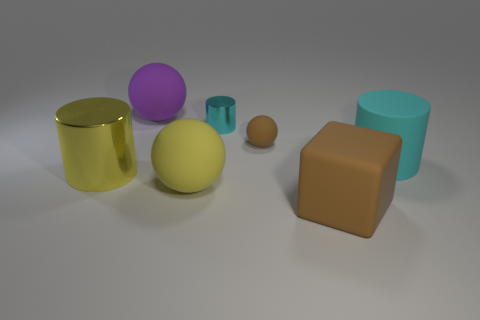Is there another tiny cyan object of the same shape as the small matte object?
Make the answer very short. No. Is the material of the cyan cylinder behind the brown sphere the same as the brown block that is in front of the big purple matte ball?
Offer a very short reply. No. What is the size of the metallic object that is on the right side of the large rubber ball in front of the large purple sphere that is to the left of the big brown block?
Ensure brevity in your answer.  Small. There is a sphere that is the same size as the cyan metallic cylinder; what is it made of?
Your answer should be compact. Rubber. Are there any green cylinders of the same size as the cyan metallic cylinder?
Provide a succinct answer. No. Do the big brown object and the small cyan shiny thing have the same shape?
Make the answer very short. No. Is there a large yellow sphere that is left of the brown thing that is to the left of the brown matte thing in front of the small rubber sphere?
Offer a very short reply. Yes. Does the brown matte thing behind the big yellow cylinder have the same size as the cyan cylinder to the right of the tiny metallic cylinder?
Your answer should be very brief. No. Is the number of large yellow cylinders that are behind the big brown thing the same as the number of large cylinders that are left of the large purple thing?
Make the answer very short. Yes. Are there any other things that are made of the same material as the big purple thing?
Provide a succinct answer. Yes. 